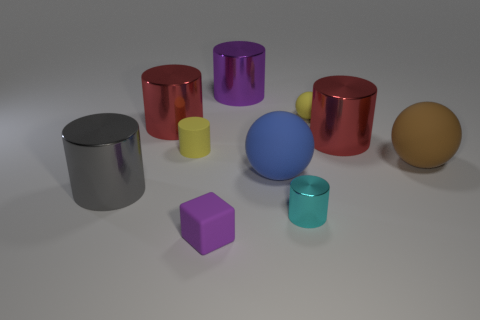What number of objects are either red metal cylinders to the left of the purple rubber object or large things on the left side of the big blue ball?
Your answer should be very brief. 3. There is a small yellow object that is the same shape as the purple shiny object; what is it made of?
Provide a short and direct response. Rubber. Are any purple cylinders visible?
Your answer should be very brief. Yes. There is a thing that is both right of the large blue object and left of the small sphere; how big is it?
Provide a succinct answer. Small. The gray object is what shape?
Offer a very short reply. Cylinder. There is a yellow rubber object to the right of the purple metallic cylinder; is there a tiny object that is to the right of it?
Give a very brief answer. No. What is the material of the cyan thing that is the same size as the yellow rubber sphere?
Your answer should be compact. Metal. Is there a yellow ball of the same size as the brown rubber thing?
Offer a very short reply. No. There is a red cylinder that is left of the tiny block; what is its material?
Keep it short and to the point. Metal. Is the sphere behind the brown rubber ball made of the same material as the blue ball?
Ensure brevity in your answer.  Yes. 